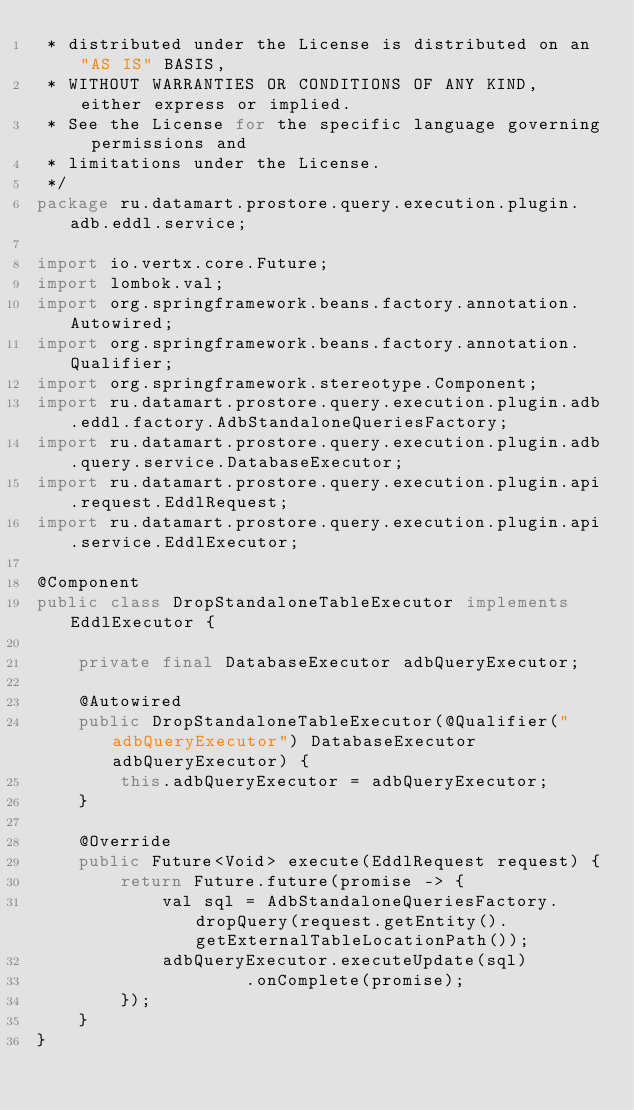<code> <loc_0><loc_0><loc_500><loc_500><_Java_> * distributed under the License is distributed on an "AS IS" BASIS,
 * WITHOUT WARRANTIES OR CONDITIONS OF ANY KIND, either express or implied.
 * See the License for the specific language governing permissions and
 * limitations under the License.
 */
package ru.datamart.prostore.query.execution.plugin.adb.eddl.service;

import io.vertx.core.Future;
import lombok.val;
import org.springframework.beans.factory.annotation.Autowired;
import org.springframework.beans.factory.annotation.Qualifier;
import org.springframework.stereotype.Component;
import ru.datamart.prostore.query.execution.plugin.adb.eddl.factory.AdbStandaloneQueriesFactory;
import ru.datamart.prostore.query.execution.plugin.adb.query.service.DatabaseExecutor;
import ru.datamart.prostore.query.execution.plugin.api.request.EddlRequest;
import ru.datamart.prostore.query.execution.plugin.api.service.EddlExecutor;

@Component
public class DropStandaloneTableExecutor implements EddlExecutor {

    private final DatabaseExecutor adbQueryExecutor;

    @Autowired
    public DropStandaloneTableExecutor(@Qualifier("adbQueryExecutor") DatabaseExecutor adbQueryExecutor) {
        this.adbQueryExecutor = adbQueryExecutor;
    }

    @Override
    public Future<Void> execute(EddlRequest request) {
        return Future.future(promise -> {
            val sql = AdbStandaloneQueriesFactory.dropQuery(request.getEntity().getExternalTableLocationPath());
            adbQueryExecutor.executeUpdate(sql)
                    .onComplete(promise);
        });
    }
}
</code> 